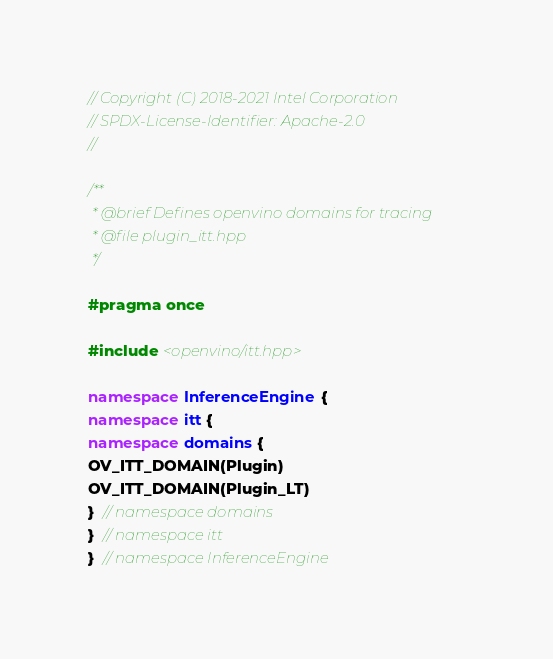Convert code to text. <code><loc_0><loc_0><loc_500><loc_500><_C++_>// Copyright (C) 2018-2021 Intel Corporation
// SPDX-License-Identifier: Apache-2.0
//

/**
 * @brief Defines openvino domains for tracing
 * @file plugin_itt.hpp
 */

#pragma once

#include <openvino/itt.hpp>

namespace InferenceEngine {
namespace itt {
namespace domains {
OV_ITT_DOMAIN(Plugin)
OV_ITT_DOMAIN(Plugin_LT)
}  // namespace domains
}  // namespace itt
}  // namespace InferenceEngine
</code> 